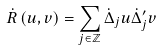Convert formula to latex. <formula><loc_0><loc_0><loc_500><loc_500>\dot { R } \left ( u , v \right ) = \sum _ { j \in \mathbb { Z } } \dot { \Delta } _ { j } u \dot { \Delta } _ { j } ^ { \prime } v</formula> 